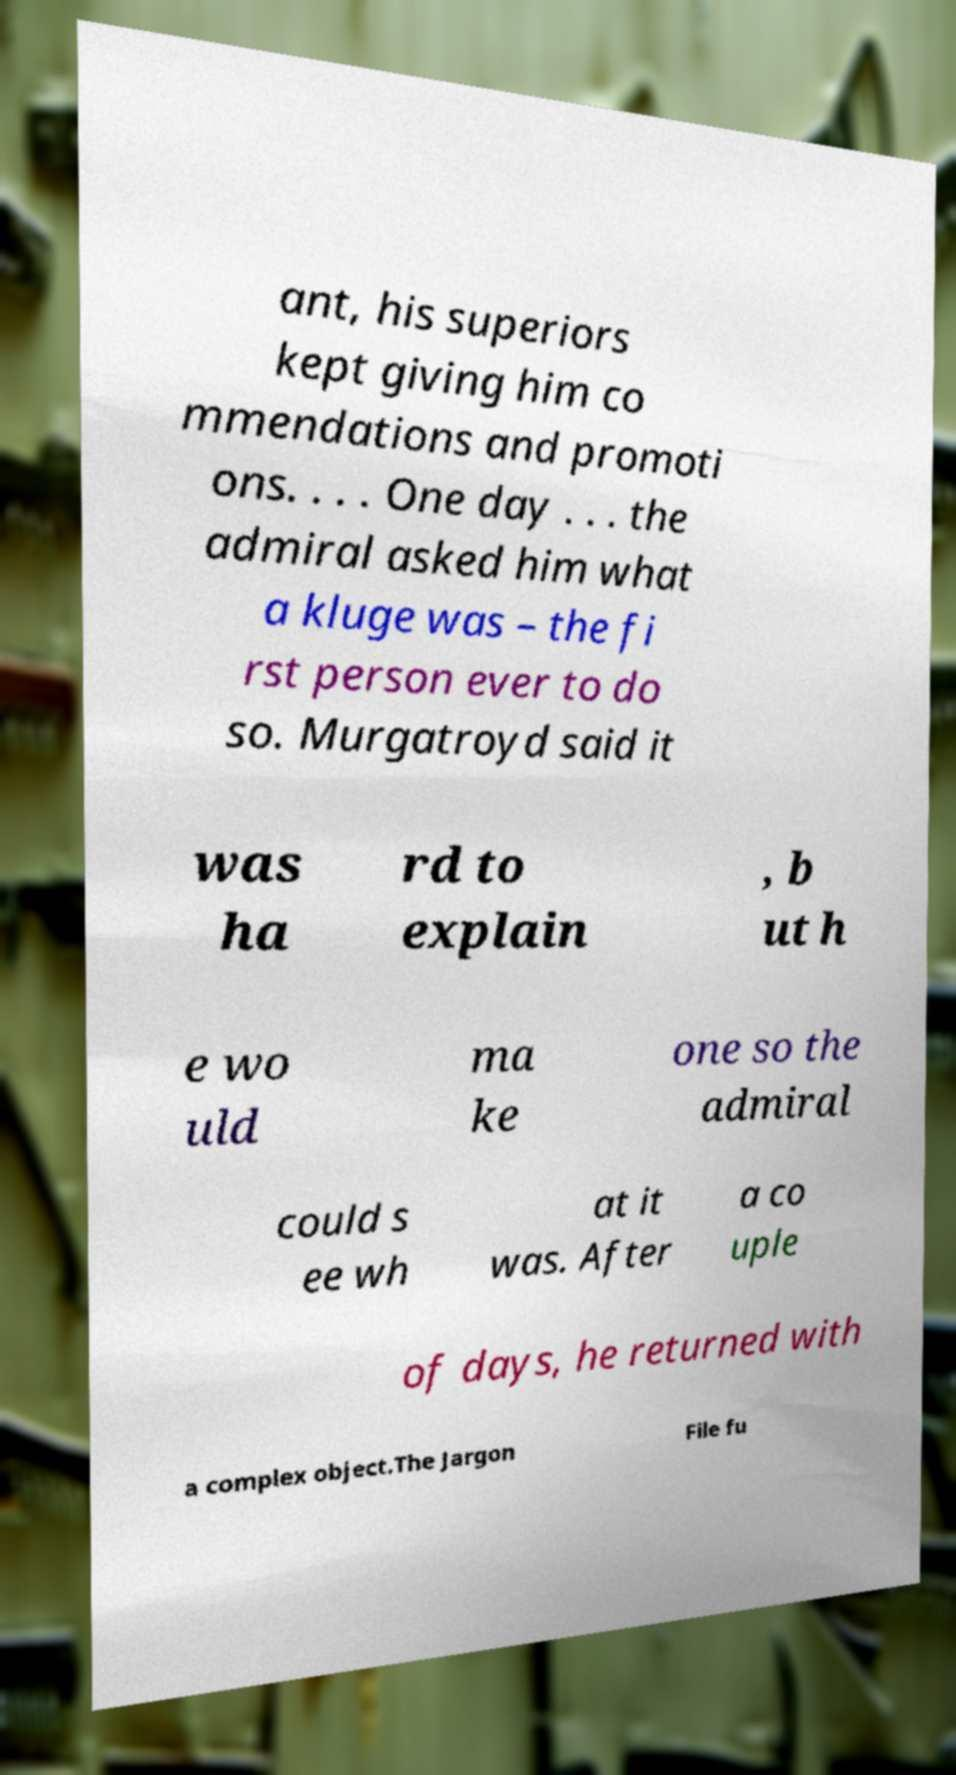For documentation purposes, I need the text within this image transcribed. Could you provide that? ant, his superiors kept giving him co mmendations and promoti ons. . . . One day . . . the admiral asked him what a kluge was – the fi rst person ever to do so. Murgatroyd said it was ha rd to explain , b ut h e wo uld ma ke one so the admiral could s ee wh at it was. After a co uple of days, he returned with a complex object.The Jargon File fu 